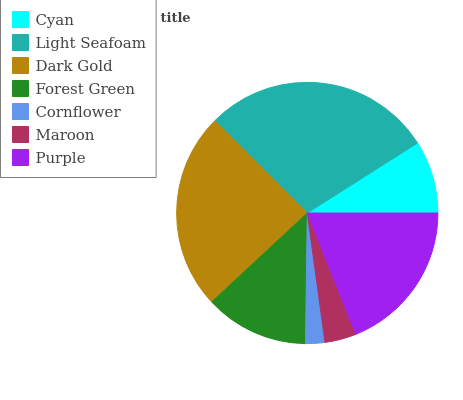Is Cornflower the minimum?
Answer yes or no. Yes. Is Light Seafoam the maximum?
Answer yes or no. Yes. Is Dark Gold the minimum?
Answer yes or no. No. Is Dark Gold the maximum?
Answer yes or no. No. Is Light Seafoam greater than Dark Gold?
Answer yes or no. Yes. Is Dark Gold less than Light Seafoam?
Answer yes or no. Yes. Is Dark Gold greater than Light Seafoam?
Answer yes or no. No. Is Light Seafoam less than Dark Gold?
Answer yes or no. No. Is Forest Green the high median?
Answer yes or no. Yes. Is Forest Green the low median?
Answer yes or no. Yes. Is Purple the high median?
Answer yes or no. No. Is Light Seafoam the low median?
Answer yes or no. No. 